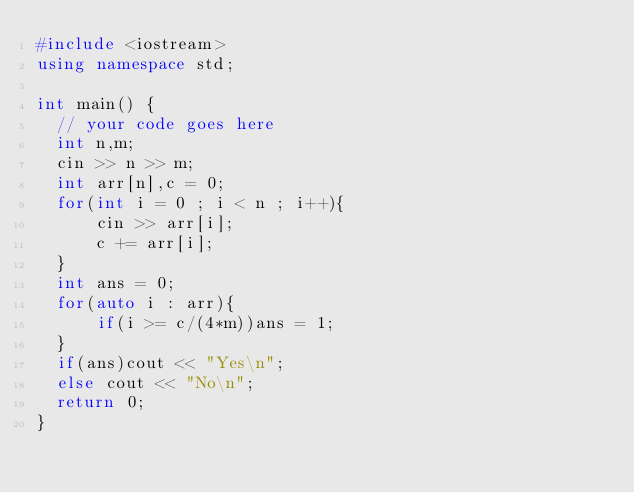Convert code to text. <code><loc_0><loc_0><loc_500><loc_500><_C++_>#include <iostream>
using namespace std;

int main() {
	// your code goes here
	int n,m;
	cin >> n >> m;
	int arr[n],c = 0;
	for(int i = 0 ; i < n ; i++){
	    cin >> arr[i];
	    c += arr[i];
	}
	int ans = 0;
	for(auto i : arr){
	    if(i >= c/(4*m))ans = 1;
	}
	if(ans)cout << "Yes\n";
	else cout << "No\n";
	return 0;
}
</code> 